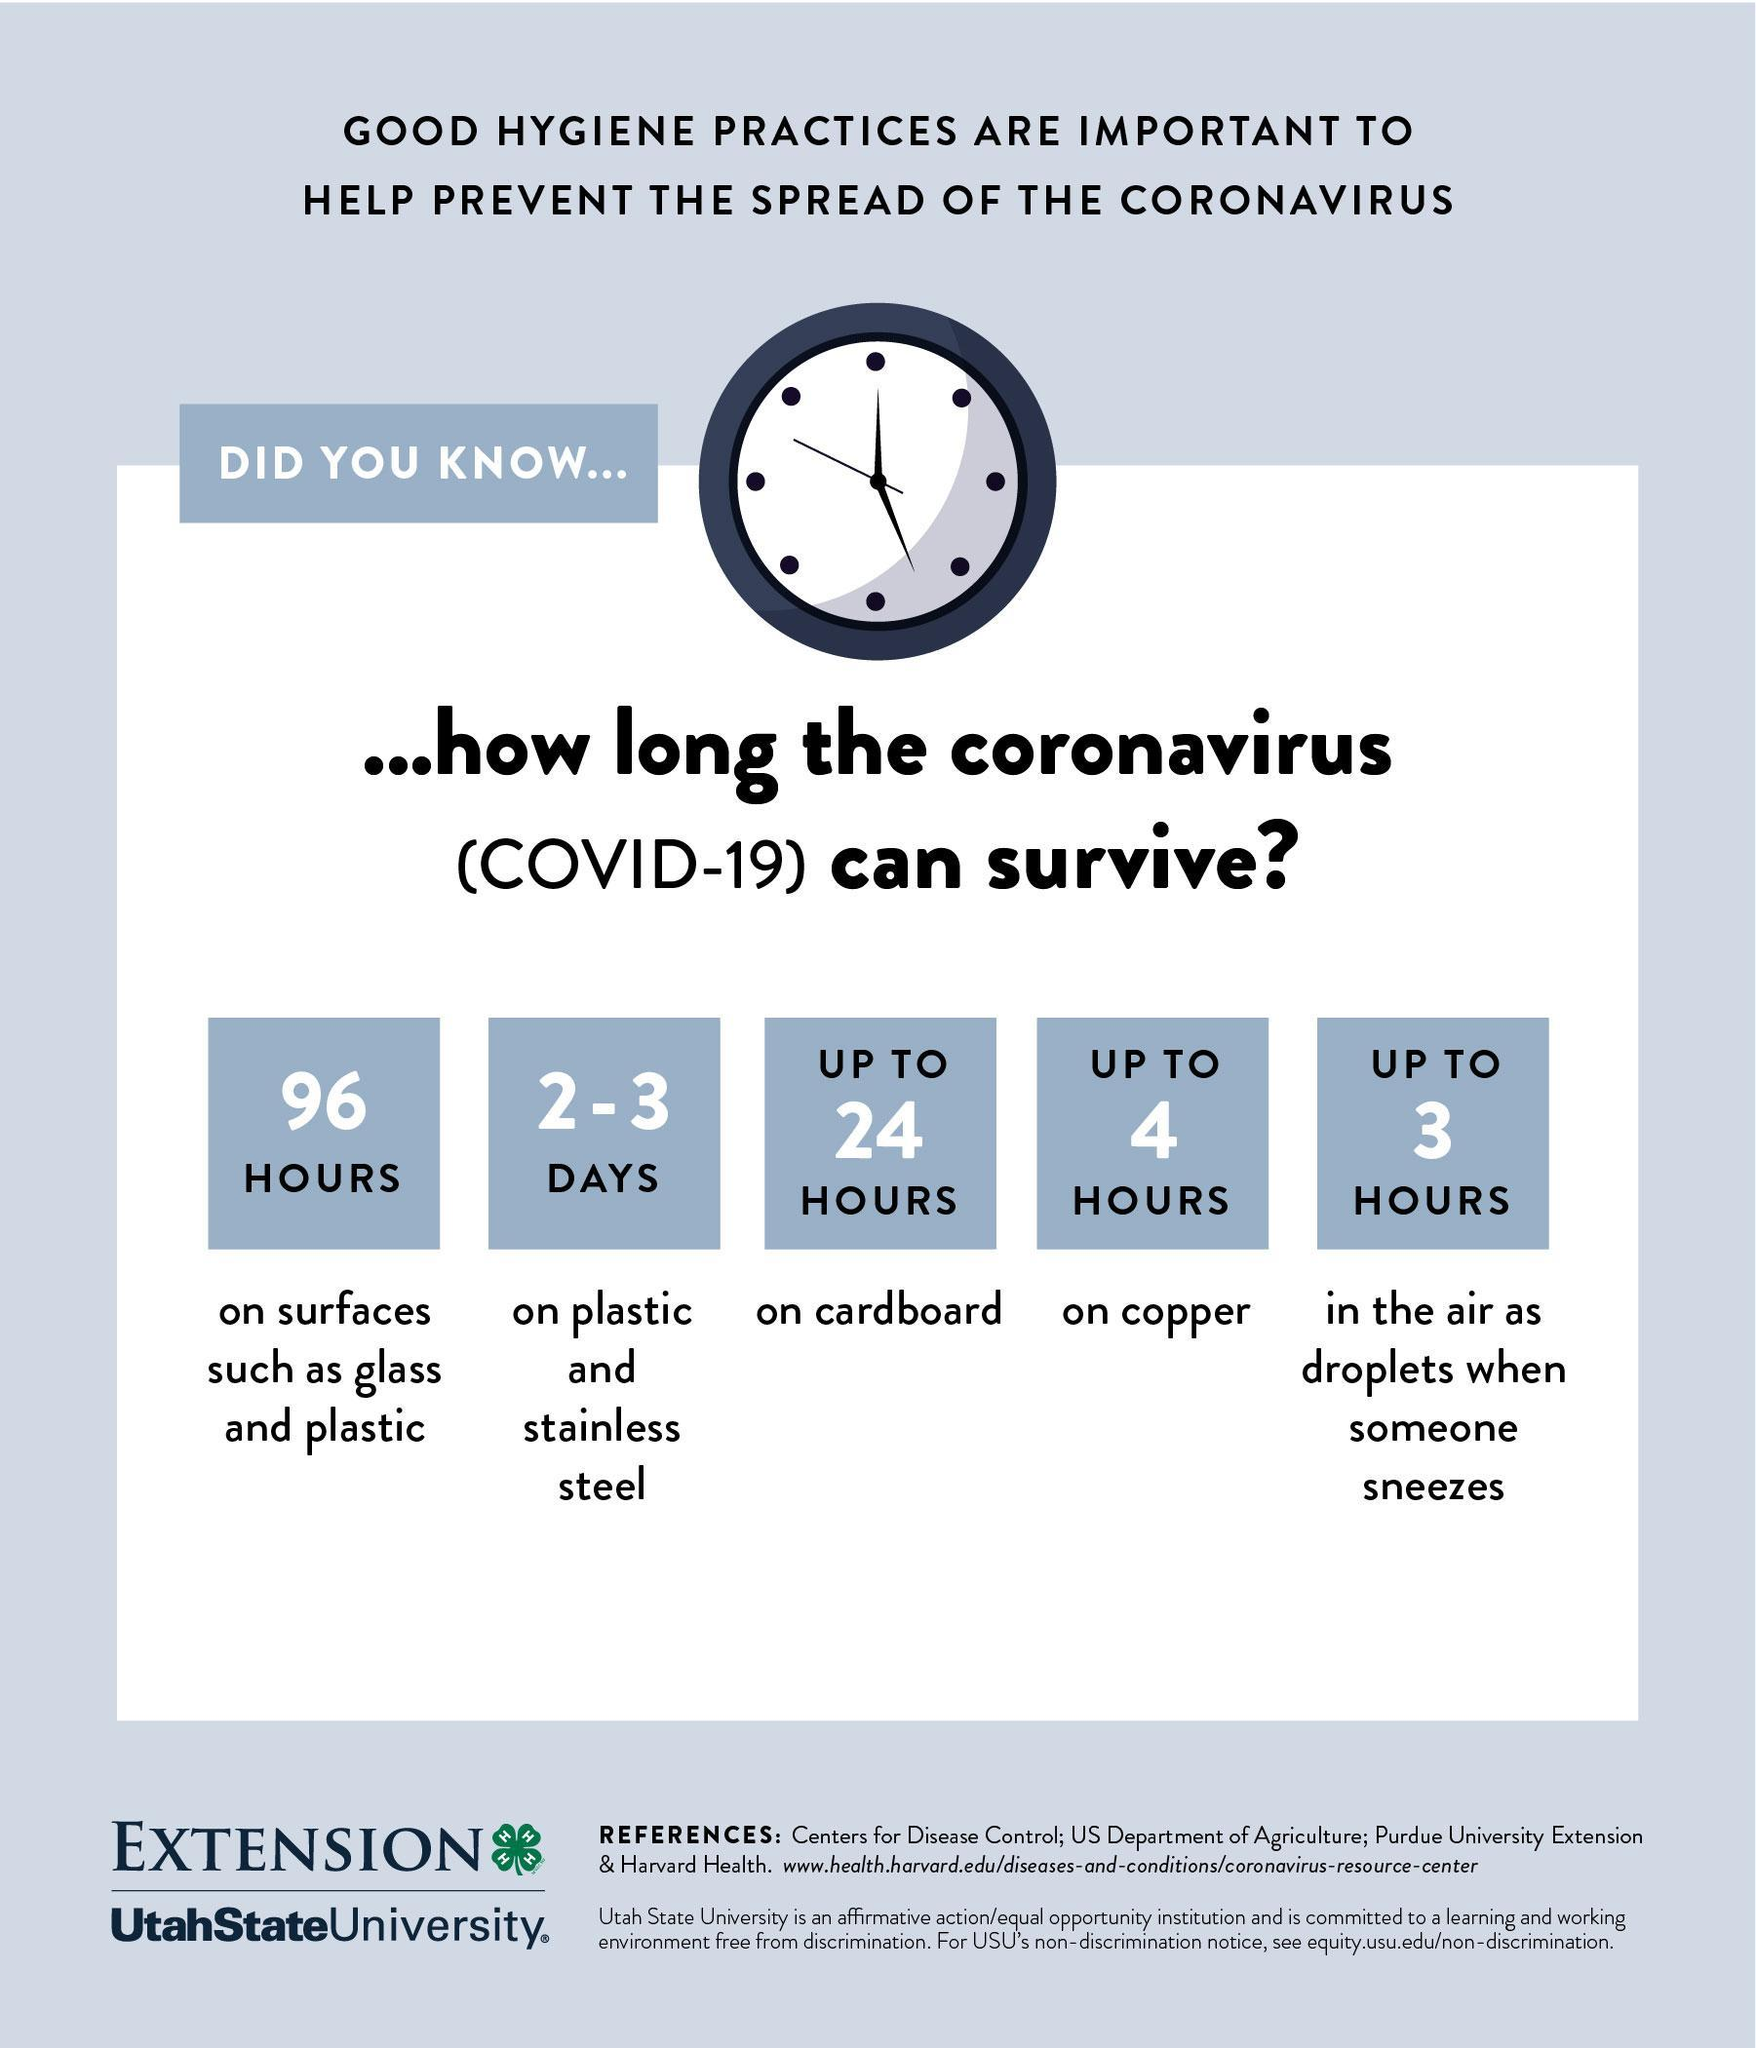The virus can survive how long on copper?
Answer the question with a short phrase. up to 4 hours The virus can survive how long in the air as droplets? up to 3 hours The virus can survive how long on glass surfaces? 96 hours The virus can survive how long on cardboard? up to 24 hours The virus can survive how long on stainless steel? 2-3 days 